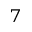Convert formula to latex. <formula><loc_0><loc_0><loc_500><loc_500>^ { 7 }</formula> 